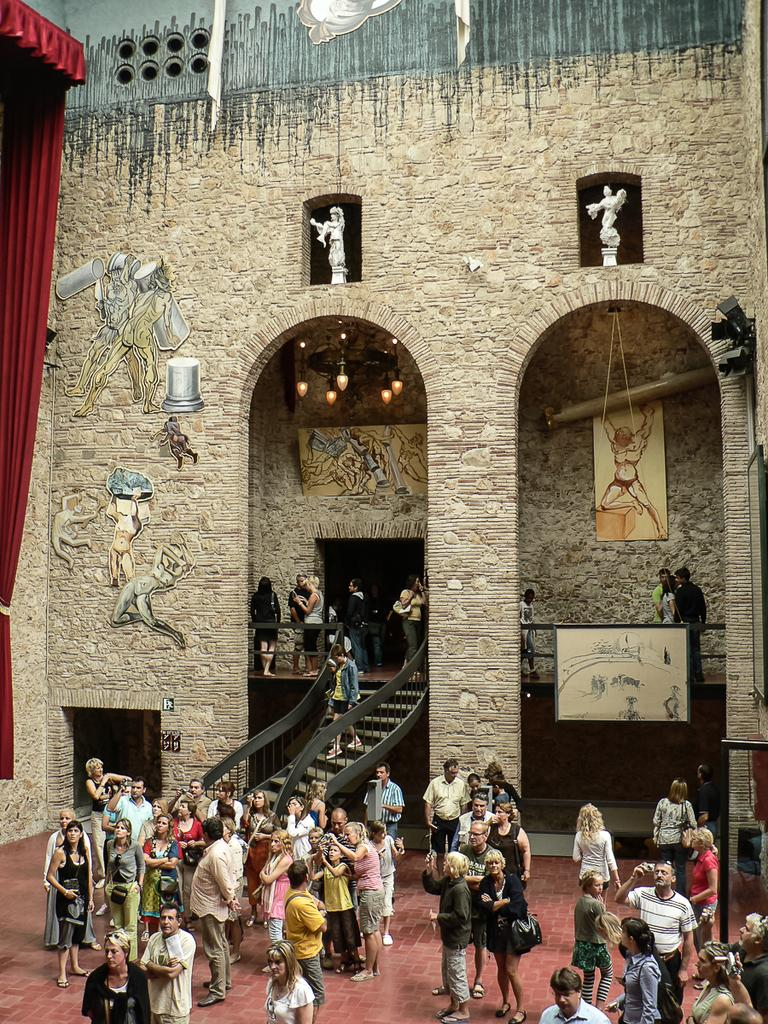What can be seen in the image involving people? There are people standing in the image. What architectural feature is present in the image? There are stairs in the image. What objects are present in the image that can be used for displaying information or art? There are boards in the image. What type of artistic objects can be seen in the image? There are sculptures in the image. What type of decorative element is present in the image? There is a red curtain in the image. What type of vandalism can be seen in the image? There is graffiti on a wall in the image. How many tongues can be seen in the image? There are no tongues present in the image. What type of coil is used to hold the sculptures in the image? There is no coil present in the image; the sculptures are not held by any coil. 